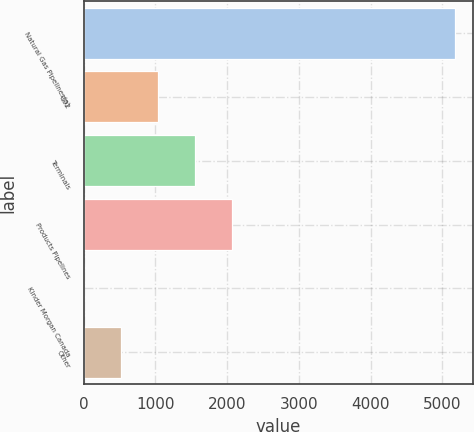Convert chart to OTSL. <chart><loc_0><loc_0><loc_500><loc_500><bar_chart><fcel>Natural Gas Pipelines(a)<fcel>CO2<fcel>Terminals<fcel>Products Pipelines<fcel>Kinder Morgan Canada<fcel>Other<nl><fcel>5174<fcel>1035.6<fcel>1552.9<fcel>2070.2<fcel>1<fcel>518.3<nl></chart> 